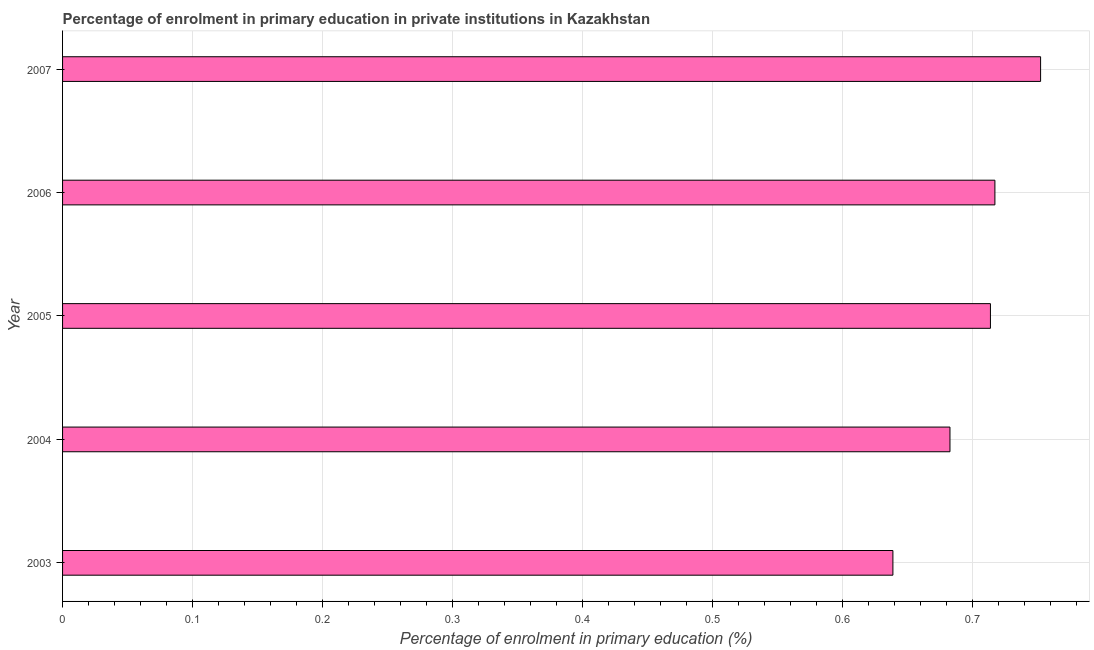What is the title of the graph?
Give a very brief answer. Percentage of enrolment in primary education in private institutions in Kazakhstan. What is the label or title of the X-axis?
Your response must be concise. Percentage of enrolment in primary education (%). What is the label or title of the Y-axis?
Ensure brevity in your answer.  Year. What is the enrolment percentage in primary education in 2005?
Your response must be concise. 0.71. Across all years, what is the maximum enrolment percentage in primary education?
Provide a succinct answer. 0.75. Across all years, what is the minimum enrolment percentage in primary education?
Your response must be concise. 0.64. What is the sum of the enrolment percentage in primary education?
Make the answer very short. 3.51. What is the difference between the enrolment percentage in primary education in 2003 and 2007?
Provide a succinct answer. -0.11. What is the average enrolment percentage in primary education per year?
Offer a very short reply. 0.7. What is the median enrolment percentage in primary education?
Provide a short and direct response. 0.71. In how many years, is the enrolment percentage in primary education greater than 0.26 %?
Ensure brevity in your answer.  5. What is the ratio of the enrolment percentage in primary education in 2003 to that in 2005?
Your response must be concise. 0.9. Is the enrolment percentage in primary education in 2003 less than that in 2007?
Offer a very short reply. Yes. Is the difference between the enrolment percentage in primary education in 2004 and 2006 greater than the difference between any two years?
Offer a terse response. No. What is the difference between the highest and the second highest enrolment percentage in primary education?
Ensure brevity in your answer.  0.04. Is the sum of the enrolment percentage in primary education in 2003 and 2006 greater than the maximum enrolment percentage in primary education across all years?
Give a very brief answer. Yes. What is the difference between the highest and the lowest enrolment percentage in primary education?
Your answer should be compact. 0.11. In how many years, is the enrolment percentage in primary education greater than the average enrolment percentage in primary education taken over all years?
Make the answer very short. 3. What is the difference between two consecutive major ticks on the X-axis?
Offer a very short reply. 0.1. Are the values on the major ticks of X-axis written in scientific E-notation?
Offer a very short reply. No. What is the Percentage of enrolment in primary education (%) in 2003?
Ensure brevity in your answer.  0.64. What is the Percentage of enrolment in primary education (%) of 2004?
Keep it short and to the point. 0.68. What is the Percentage of enrolment in primary education (%) in 2005?
Give a very brief answer. 0.71. What is the Percentage of enrolment in primary education (%) of 2006?
Ensure brevity in your answer.  0.72. What is the Percentage of enrolment in primary education (%) in 2007?
Offer a very short reply. 0.75. What is the difference between the Percentage of enrolment in primary education (%) in 2003 and 2004?
Your answer should be very brief. -0.04. What is the difference between the Percentage of enrolment in primary education (%) in 2003 and 2005?
Offer a terse response. -0.08. What is the difference between the Percentage of enrolment in primary education (%) in 2003 and 2006?
Offer a very short reply. -0.08. What is the difference between the Percentage of enrolment in primary education (%) in 2003 and 2007?
Ensure brevity in your answer.  -0.11. What is the difference between the Percentage of enrolment in primary education (%) in 2004 and 2005?
Give a very brief answer. -0.03. What is the difference between the Percentage of enrolment in primary education (%) in 2004 and 2006?
Your answer should be very brief. -0.03. What is the difference between the Percentage of enrolment in primary education (%) in 2004 and 2007?
Offer a very short reply. -0.07. What is the difference between the Percentage of enrolment in primary education (%) in 2005 and 2006?
Make the answer very short. -0. What is the difference between the Percentage of enrolment in primary education (%) in 2005 and 2007?
Ensure brevity in your answer.  -0.04. What is the difference between the Percentage of enrolment in primary education (%) in 2006 and 2007?
Ensure brevity in your answer.  -0.04. What is the ratio of the Percentage of enrolment in primary education (%) in 2003 to that in 2004?
Your response must be concise. 0.94. What is the ratio of the Percentage of enrolment in primary education (%) in 2003 to that in 2005?
Offer a terse response. 0.9. What is the ratio of the Percentage of enrolment in primary education (%) in 2003 to that in 2006?
Provide a short and direct response. 0.89. What is the ratio of the Percentage of enrolment in primary education (%) in 2003 to that in 2007?
Offer a terse response. 0.85. What is the ratio of the Percentage of enrolment in primary education (%) in 2004 to that in 2005?
Your answer should be very brief. 0.96. What is the ratio of the Percentage of enrolment in primary education (%) in 2004 to that in 2007?
Your answer should be compact. 0.91. What is the ratio of the Percentage of enrolment in primary education (%) in 2005 to that in 2007?
Ensure brevity in your answer.  0.95. What is the ratio of the Percentage of enrolment in primary education (%) in 2006 to that in 2007?
Offer a very short reply. 0.95. 